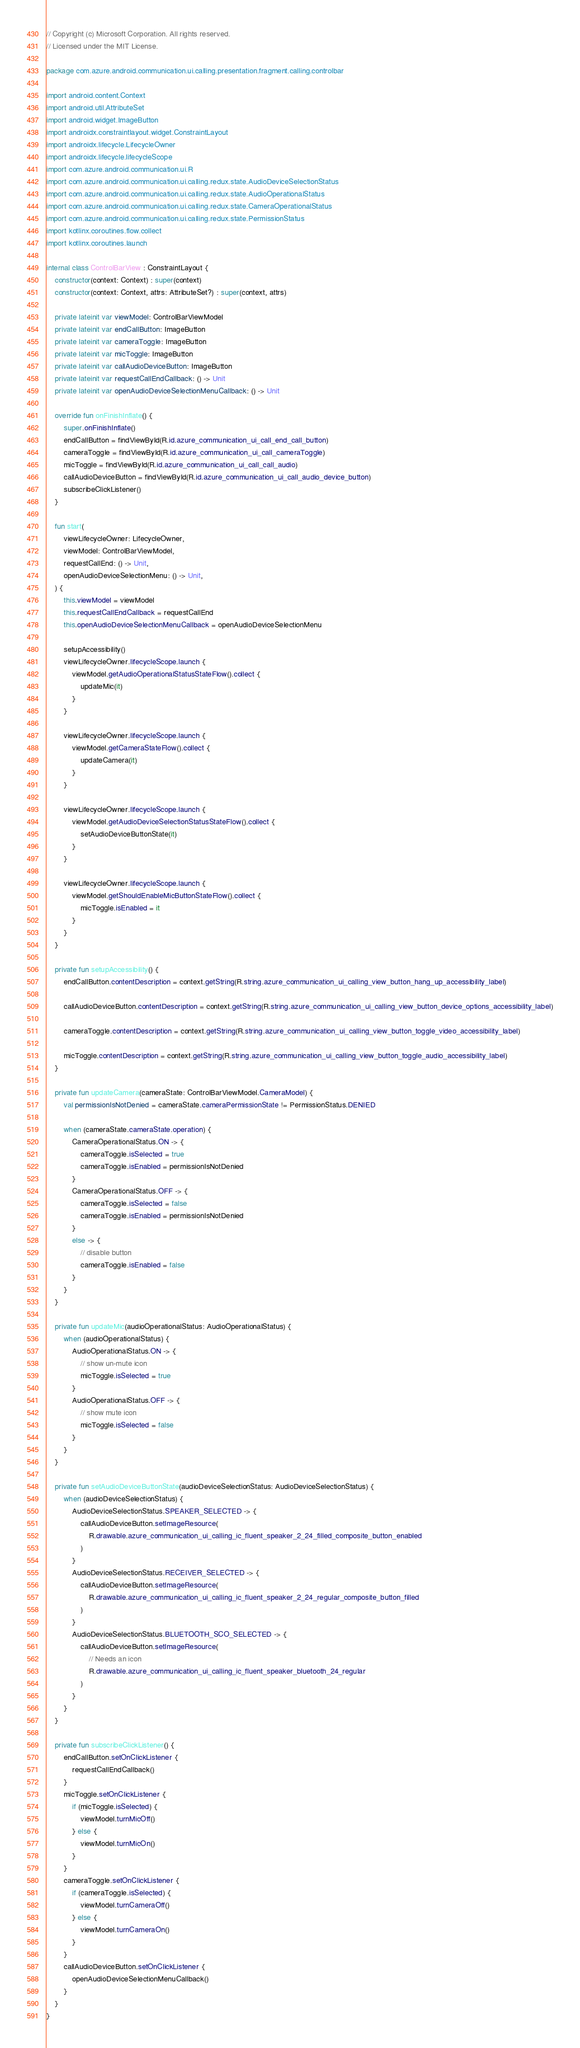Convert code to text. <code><loc_0><loc_0><loc_500><loc_500><_Kotlin_>// Copyright (c) Microsoft Corporation. All rights reserved.
// Licensed under the MIT License.

package com.azure.android.communication.ui.calling.presentation.fragment.calling.controlbar

import android.content.Context
import android.util.AttributeSet
import android.widget.ImageButton
import androidx.constraintlayout.widget.ConstraintLayout
import androidx.lifecycle.LifecycleOwner
import androidx.lifecycle.lifecycleScope
import com.azure.android.communication.ui.R
import com.azure.android.communication.ui.calling.redux.state.AudioDeviceSelectionStatus
import com.azure.android.communication.ui.calling.redux.state.AudioOperationalStatus
import com.azure.android.communication.ui.calling.redux.state.CameraOperationalStatus
import com.azure.android.communication.ui.calling.redux.state.PermissionStatus
import kotlinx.coroutines.flow.collect
import kotlinx.coroutines.launch

internal class ControlBarView : ConstraintLayout {
    constructor(context: Context) : super(context)
    constructor(context: Context, attrs: AttributeSet?) : super(context, attrs)

    private lateinit var viewModel: ControlBarViewModel
    private lateinit var endCallButton: ImageButton
    private lateinit var cameraToggle: ImageButton
    private lateinit var micToggle: ImageButton
    private lateinit var callAudioDeviceButton: ImageButton
    private lateinit var requestCallEndCallback: () -> Unit
    private lateinit var openAudioDeviceSelectionMenuCallback: () -> Unit

    override fun onFinishInflate() {
        super.onFinishInflate()
        endCallButton = findViewById(R.id.azure_communication_ui_call_end_call_button)
        cameraToggle = findViewById(R.id.azure_communication_ui_call_cameraToggle)
        micToggle = findViewById(R.id.azure_communication_ui_call_call_audio)
        callAudioDeviceButton = findViewById(R.id.azure_communication_ui_call_audio_device_button)
        subscribeClickListener()
    }

    fun start(
        viewLifecycleOwner: LifecycleOwner,
        viewModel: ControlBarViewModel,
        requestCallEnd: () -> Unit,
        openAudioDeviceSelectionMenu: () -> Unit,
    ) {
        this.viewModel = viewModel
        this.requestCallEndCallback = requestCallEnd
        this.openAudioDeviceSelectionMenuCallback = openAudioDeviceSelectionMenu

        setupAccessibility()
        viewLifecycleOwner.lifecycleScope.launch {
            viewModel.getAudioOperationalStatusStateFlow().collect {
                updateMic(it)
            }
        }

        viewLifecycleOwner.lifecycleScope.launch {
            viewModel.getCameraStateFlow().collect {
                updateCamera(it)
            }
        }

        viewLifecycleOwner.lifecycleScope.launch {
            viewModel.getAudioDeviceSelectionStatusStateFlow().collect {
                setAudioDeviceButtonState(it)
            }
        }

        viewLifecycleOwner.lifecycleScope.launch {
            viewModel.getShouldEnableMicButtonStateFlow().collect {
                micToggle.isEnabled = it
            }
        }
    }

    private fun setupAccessibility() {
        endCallButton.contentDescription = context.getString(R.string.azure_communication_ui_calling_view_button_hang_up_accessibility_label)

        callAudioDeviceButton.contentDescription = context.getString(R.string.azure_communication_ui_calling_view_button_device_options_accessibility_label)

        cameraToggle.contentDescription = context.getString(R.string.azure_communication_ui_calling_view_button_toggle_video_accessibility_label)

        micToggle.contentDescription = context.getString(R.string.azure_communication_ui_calling_view_button_toggle_audio_accessibility_label)
    }

    private fun updateCamera(cameraState: ControlBarViewModel.CameraModel) {
        val permissionIsNotDenied = cameraState.cameraPermissionState != PermissionStatus.DENIED

        when (cameraState.cameraState.operation) {
            CameraOperationalStatus.ON -> {
                cameraToggle.isSelected = true
                cameraToggle.isEnabled = permissionIsNotDenied
            }
            CameraOperationalStatus.OFF -> {
                cameraToggle.isSelected = false
                cameraToggle.isEnabled = permissionIsNotDenied
            }
            else -> {
                // disable button
                cameraToggle.isEnabled = false
            }
        }
    }

    private fun updateMic(audioOperationalStatus: AudioOperationalStatus) {
        when (audioOperationalStatus) {
            AudioOperationalStatus.ON -> {
                // show un-mute icon
                micToggle.isSelected = true
            }
            AudioOperationalStatus.OFF -> {
                // show mute icon
                micToggle.isSelected = false
            }
        }
    }

    private fun setAudioDeviceButtonState(audioDeviceSelectionStatus: AudioDeviceSelectionStatus) {
        when (audioDeviceSelectionStatus) {
            AudioDeviceSelectionStatus.SPEAKER_SELECTED -> {
                callAudioDeviceButton.setImageResource(
                    R.drawable.azure_communication_ui_calling_ic_fluent_speaker_2_24_filled_composite_button_enabled
                )
            }
            AudioDeviceSelectionStatus.RECEIVER_SELECTED -> {
                callAudioDeviceButton.setImageResource(
                    R.drawable.azure_communication_ui_calling_ic_fluent_speaker_2_24_regular_composite_button_filled
                )
            }
            AudioDeviceSelectionStatus.BLUETOOTH_SCO_SELECTED -> {
                callAudioDeviceButton.setImageResource(
                    // Needs an icon
                    R.drawable.azure_communication_ui_calling_ic_fluent_speaker_bluetooth_24_regular
                )
            }
        }
    }

    private fun subscribeClickListener() {
        endCallButton.setOnClickListener {
            requestCallEndCallback()
        }
        micToggle.setOnClickListener {
            if (micToggle.isSelected) {
                viewModel.turnMicOff()
            } else {
                viewModel.turnMicOn()
            }
        }
        cameraToggle.setOnClickListener {
            if (cameraToggle.isSelected) {
                viewModel.turnCameraOff()
            } else {
                viewModel.turnCameraOn()
            }
        }
        callAudioDeviceButton.setOnClickListener {
            openAudioDeviceSelectionMenuCallback()
        }
    }
}
</code> 